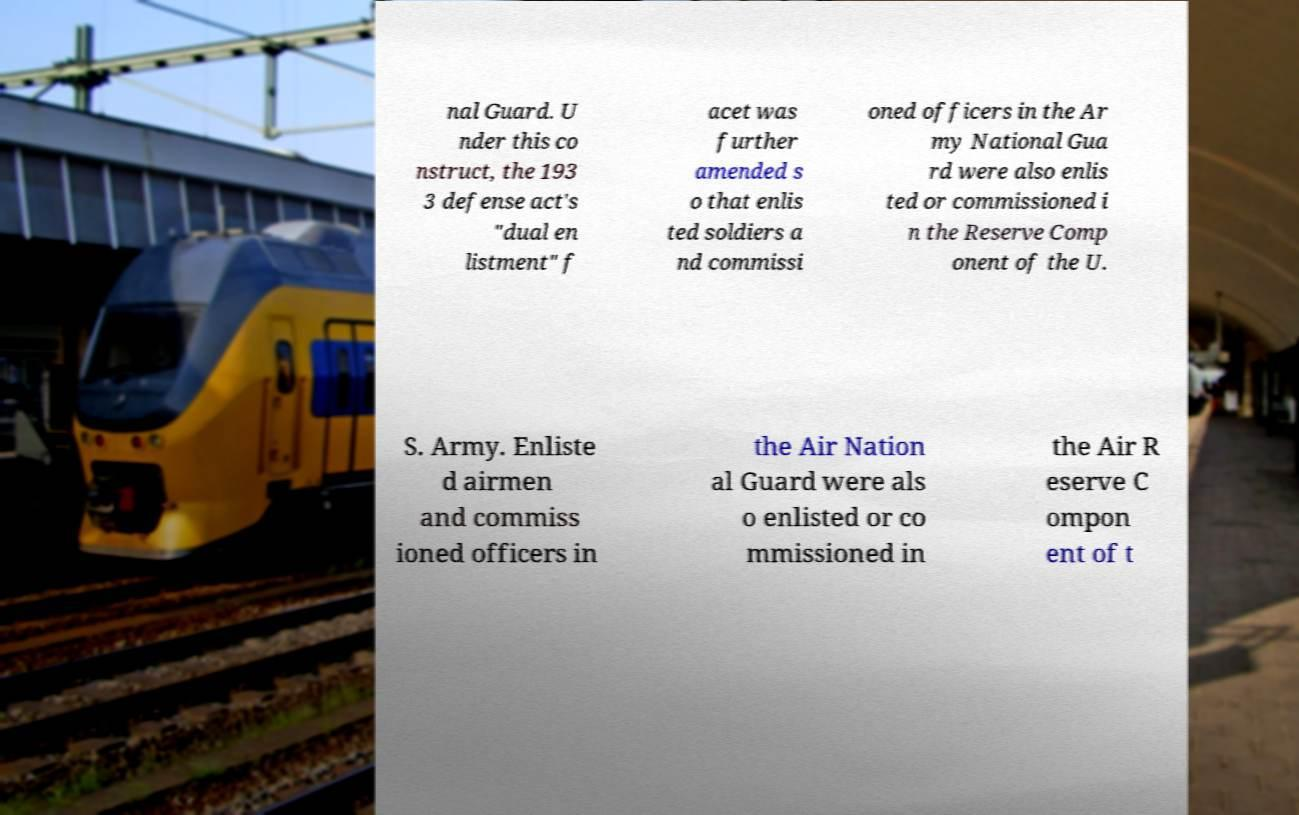Could you assist in decoding the text presented in this image and type it out clearly? nal Guard. U nder this co nstruct, the 193 3 defense act's "dual en listment" f acet was further amended s o that enlis ted soldiers a nd commissi oned officers in the Ar my National Gua rd were also enlis ted or commissioned i n the Reserve Comp onent of the U. S. Army. Enliste d airmen and commiss ioned officers in the Air Nation al Guard were als o enlisted or co mmissioned in the Air R eserve C ompon ent of t 